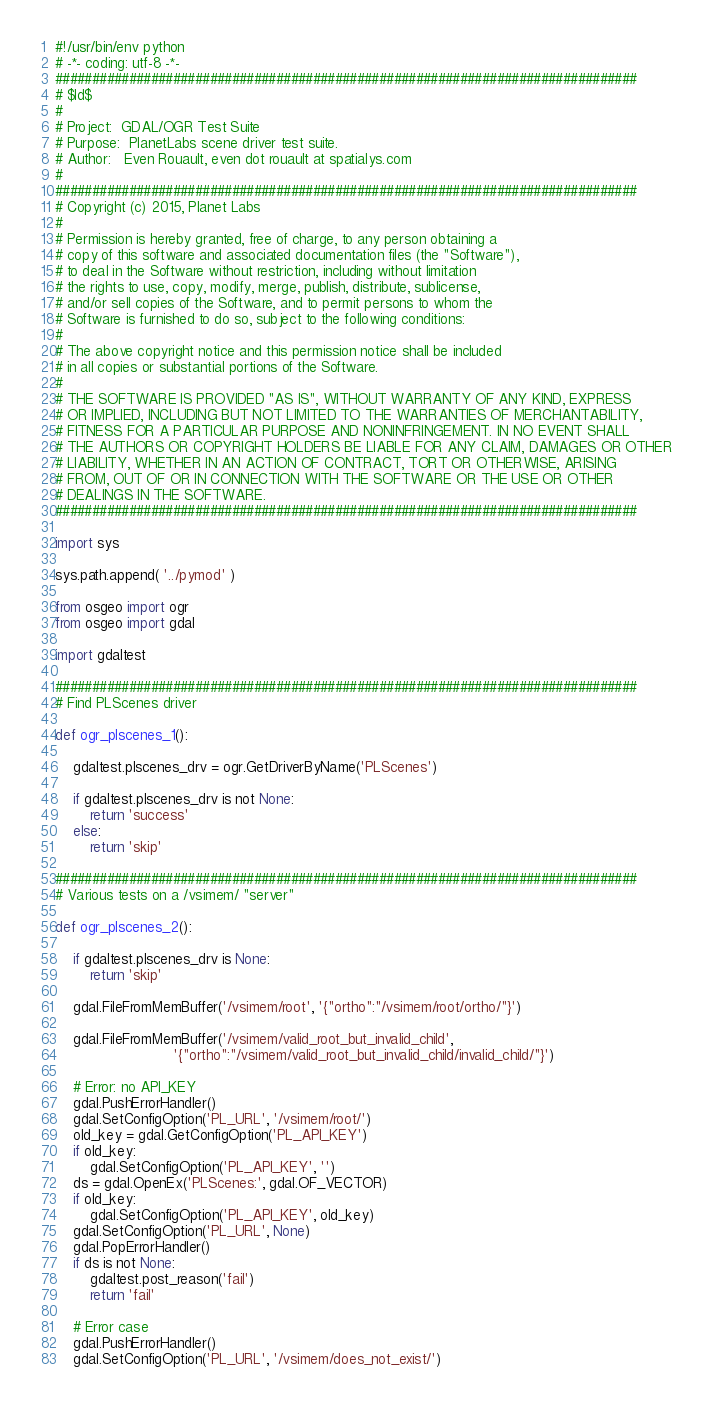<code> <loc_0><loc_0><loc_500><loc_500><_Python_>#!/usr/bin/env python
# -*- coding: utf-8 -*-
###############################################################################
# $Id$
#
# Project:  GDAL/OGR Test Suite
# Purpose:  PlanetLabs scene driver test suite.
# Author:   Even Rouault, even dot rouault at spatialys.com
#
###############################################################################
# Copyright (c) 2015, Planet Labs
#
# Permission is hereby granted, free of charge, to any person obtaining a
# copy of this software and associated documentation files (the "Software"),
# to deal in the Software without restriction, including without limitation
# the rights to use, copy, modify, merge, publish, distribute, sublicense,
# and/or sell copies of the Software, and to permit persons to whom the
# Software is furnished to do so, subject to the following conditions:
#
# The above copyright notice and this permission notice shall be included
# in all copies or substantial portions of the Software.
#
# THE SOFTWARE IS PROVIDED "AS IS", WITHOUT WARRANTY OF ANY KIND, EXPRESS
# OR IMPLIED, INCLUDING BUT NOT LIMITED TO THE WARRANTIES OF MERCHANTABILITY,
# FITNESS FOR A PARTICULAR PURPOSE AND NONINFRINGEMENT. IN NO EVENT SHALL
# THE AUTHORS OR COPYRIGHT HOLDERS BE LIABLE FOR ANY CLAIM, DAMAGES OR OTHER
# LIABILITY, WHETHER IN AN ACTION OF CONTRACT, TORT OR OTHERWISE, ARISING
# FROM, OUT OF OR IN CONNECTION WITH THE SOFTWARE OR THE USE OR OTHER
# DEALINGS IN THE SOFTWARE.
###############################################################################

import sys

sys.path.append( '../pymod' )

from osgeo import ogr
from osgeo import gdal

import gdaltest

###############################################################################
# Find PLScenes driver

def ogr_plscenes_1():

    gdaltest.plscenes_drv = ogr.GetDriverByName('PLScenes')

    if gdaltest.plscenes_drv is not None:
        return 'success'
    else:
        return 'skip'

###############################################################################
# Various tests on a /vsimem/ "server"

def ogr_plscenes_2():

    if gdaltest.plscenes_drv is None:
        return 'skip'

    gdal.FileFromMemBuffer('/vsimem/root', '{"ortho":"/vsimem/root/ortho/"}')

    gdal.FileFromMemBuffer('/vsimem/valid_root_but_invalid_child',
                           '{"ortho":"/vsimem/valid_root_but_invalid_child/invalid_child/"}')

    # Error: no API_KEY
    gdal.PushErrorHandler()
    gdal.SetConfigOption('PL_URL', '/vsimem/root/')
    old_key = gdal.GetConfigOption('PL_API_KEY')
    if old_key:
        gdal.SetConfigOption('PL_API_KEY', '')
    ds = gdal.OpenEx('PLScenes:', gdal.OF_VECTOR)
    if old_key:
        gdal.SetConfigOption('PL_API_KEY', old_key)
    gdal.SetConfigOption('PL_URL', None)
    gdal.PopErrorHandler()
    if ds is not None:
        gdaltest.post_reason('fail')
        return 'fail'

    # Error case
    gdal.PushErrorHandler()
    gdal.SetConfigOption('PL_URL', '/vsimem/does_not_exist/')</code> 